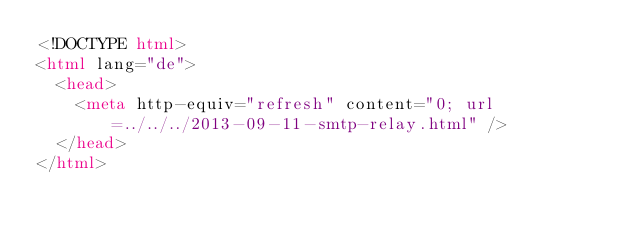<code> <loc_0><loc_0><loc_500><loc_500><_HTML_><!DOCTYPE html>
<html lang="de">
  <head>
    <meta http-equiv="refresh" content="0; url=../../../2013-09-11-smtp-relay.html" />
  </head>
</html>
</code> 